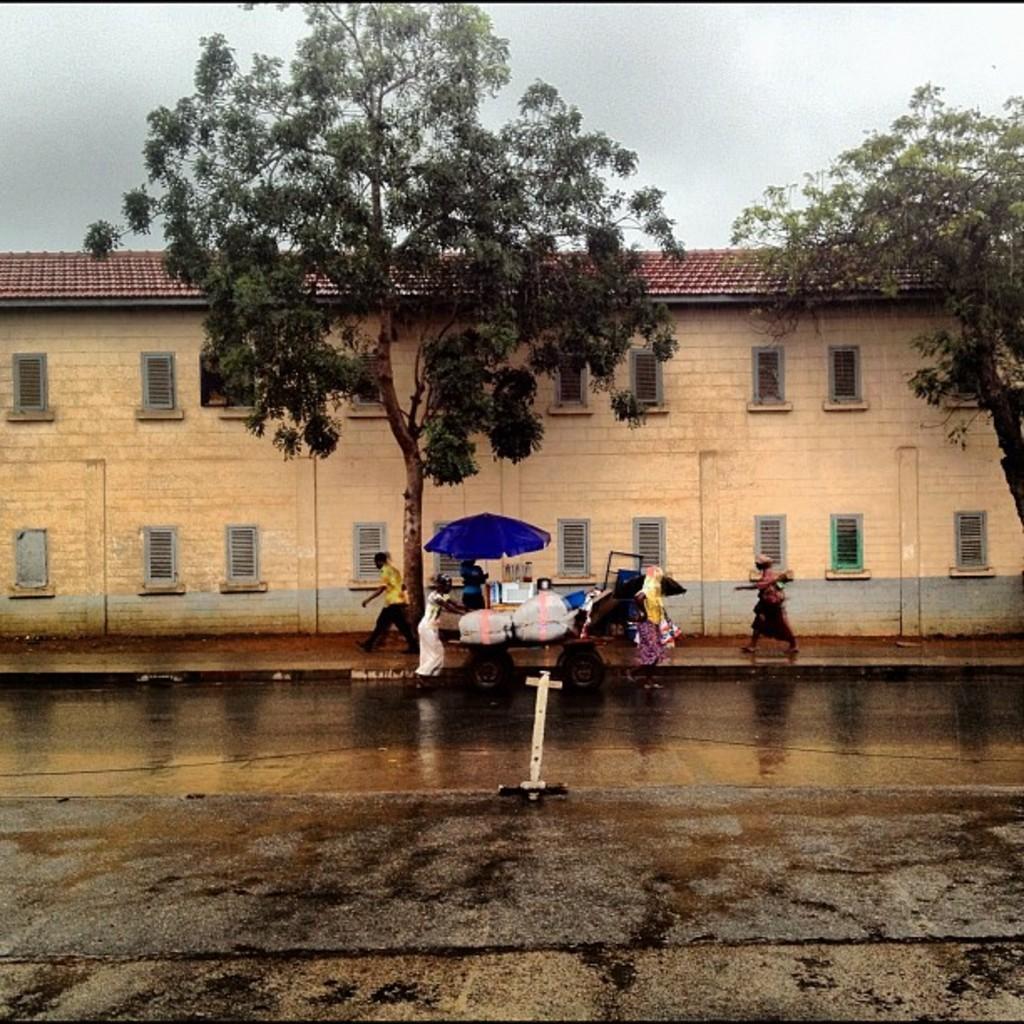Please provide a concise description of this image. This is a building with the windows and a roof. I can see the leaves with branches and leaves. There are few people walking. This looks like an umbrella, which is blue in color. I can see a wheel cart with few objects on it. Here is the sky. This looks like a road. 